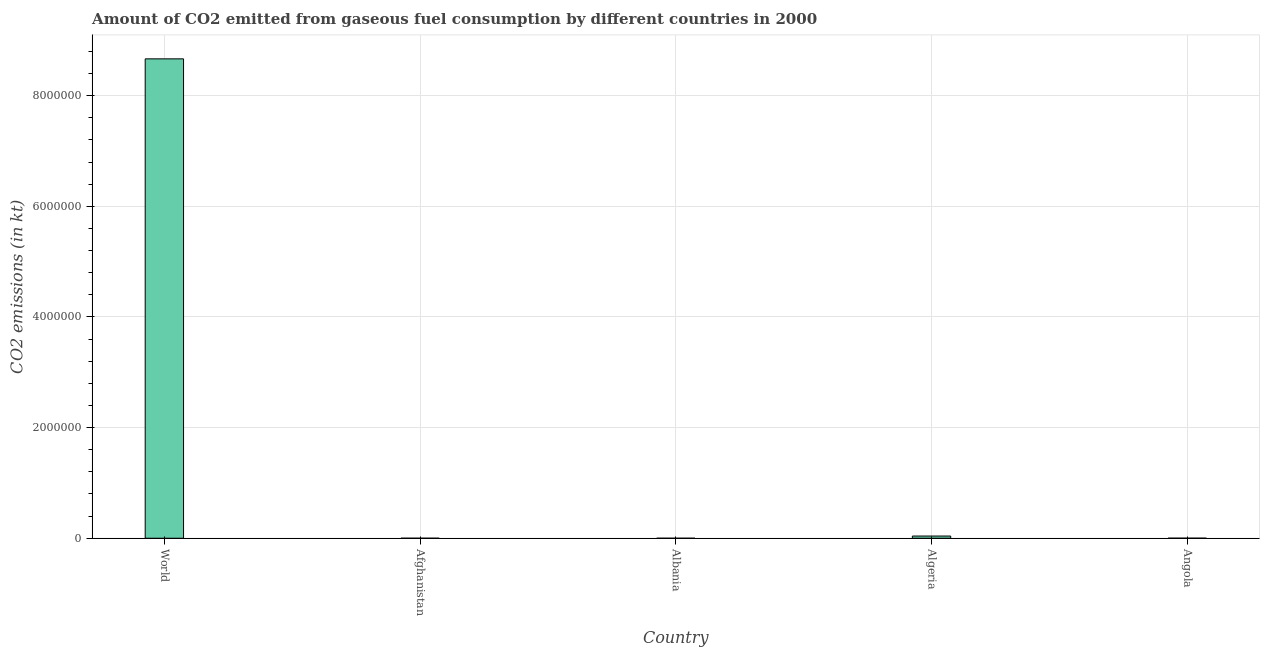Does the graph contain any zero values?
Your answer should be very brief. No. What is the title of the graph?
Offer a very short reply. Amount of CO2 emitted from gaseous fuel consumption by different countries in 2000. What is the label or title of the Y-axis?
Offer a very short reply. CO2 emissions (in kt). What is the co2 emissions from gaseous fuel consumption in Angola?
Offer a very short reply. 1085.43. Across all countries, what is the maximum co2 emissions from gaseous fuel consumption?
Make the answer very short. 8.67e+06. Across all countries, what is the minimum co2 emissions from gaseous fuel consumption?
Make the answer very short. 22. In which country was the co2 emissions from gaseous fuel consumption minimum?
Offer a very short reply. Albania. What is the sum of the co2 emissions from gaseous fuel consumption?
Ensure brevity in your answer.  8.71e+06. What is the difference between the co2 emissions from gaseous fuel consumption in Afghanistan and Albania?
Give a very brief answer. 201.69. What is the average co2 emissions from gaseous fuel consumption per country?
Offer a terse response. 1.74e+06. What is the median co2 emissions from gaseous fuel consumption?
Make the answer very short. 1085.43. What is the ratio of the co2 emissions from gaseous fuel consumption in Afghanistan to that in Albania?
Keep it short and to the point. 10.17. What is the difference between the highest and the second highest co2 emissions from gaseous fuel consumption?
Offer a very short reply. 8.63e+06. What is the difference between the highest and the lowest co2 emissions from gaseous fuel consumption?
Keep it short and to the point. 8.67e+06. How many bars are there?
Give a very brief answer. 5. What is the CO2 emissions (in kt) in World?
Provide a short and direct response. 8.67e+06. What is the CO2 emissions (in kt) of Afghanistan?
Offer a very short reply. 223.69. What is the CO2 emissions (in kt) of Albania?
Offer a terse response. 22. What is the CO2 emissions (in kt) of Algeria?
Ensure brevity in your answer.  3.97e+04. What is the CO2 emissions (in kt) in Angola?
Your answer should be compact. 1085.43. What is the difference between the CO2 emissions (in kt) in World and Afghanistan?
Offer a terse response. 8.66e+06. What is the difference between the CO2 emissions (in kt) in World and Albania?
Give a very brief answer. 8.67e+06. What is the difference between the CO2 emissions (in kt) in World and Algeria?
Ensure brevity in your answer.  8.63e+06. What is the difference between the CO2 emissions (in kt) in World and Angola?
Provide a succinct answer. 8.66e+06. What is the difference between the CO2 emissions (in kt) in Afghanistan and Albania?
Your answer should be compact. 201.69. What is the difference between the CO2 emissions (in kt) in Afghanistan and Algeria?
Ensure brevity in your answer.  -3.95e+04. What is the difference between the CO2 emissions (in kt) in Afghanistan and Angola?
Your answer should be compact. -861.75. What is the difference between the CO2 emissions (in kt) in Albania and Algeria?
Keep it short and to the point. -3.97e+04. What is the difference between the CO2 emissions (in kt) in Albania and Angola?
Offer a very short reply. -1063.43. What is the difference between the CO2 emissions (in kt) in Algeria and Angola?
Your response must be concise. 3.87e+04. What is the ratio of the CO2 emissions (in kt) in World to that in Afghanistan?
Offer a very short reply. 3.87e+04. What is the ratio of the CO2 emissions (in kt) in World to that in Albania?
Make the answer very short. 3.94e+05. What is the ratio of the CO2 emissions (in kt) in World to that in Algeria?
Ensure brevity in your answer.  218.03. What is the ratio of the CO2 emissions (in kt) in World to that in Angola?
Your response must be concise. 7983.11. What is the ratio of the CO2 emissions (in kt) in Afghanistan to that in Albania?
Keep it short and to the point. 10.17. What is the ratio of the CO2 emissions (in kt) in Afghanistan to that in Algeria?
Give a very brief answer. 0.01. What is the ratio of the CO2 emissions (in kt) in Afghanistan to that in Angola?
Your answer should be compact. 0.21. What is the ratio of the CO2 emissions (in kt) in Albania to that in Algeria?
Ensure brevity in your answer.  0. What is the ratio of the CO2 emissions (in kt) in Albania to that in Angola?
Your answer should be compact. 0.02. What is the ratio of the CO2 emissions (in kt) in Algeria to that in Angola?
Your response must be concise. 36.62. 